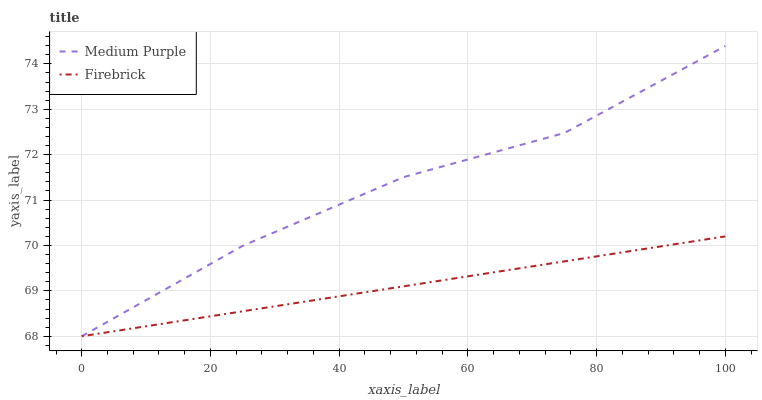Does Firebrick have the minimum area under the curve?
Answer yes or no. Yes. Does Medium Purple have the maximum area under the curve?
Answer yes or no. Yes. Does Firebrick have the maximum area under the curve?
Answer yes or no. No. Is Firebrick the smoothest?
Answer yes or no. Yes. Is Medium Purple the roughest?
Answer yes or no. Yes. Is Firebrick the roughest?
Answer yes or no. No. Does Medium Purple have the highest value?
Answer yes or no. Yes. Does Firebrick have the highest value?
Answer yes or no. No. 